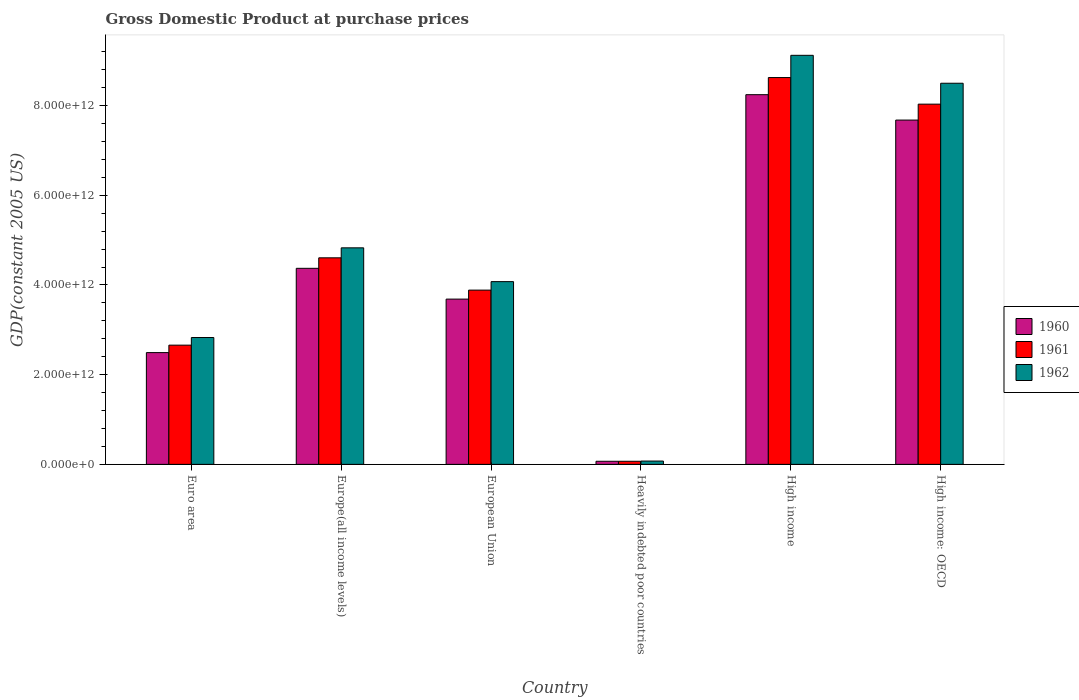How many groups of bars are there?
Provide a short and direct response. 6. Are the number of bars per tick equal to the number of legend labels?
Offer a very short reply. Yes. Are the number of bars on each tick of the X-axis equal?
Your answer should be very brief. Yes. How many bars are there on the 6th tick from the left?
Your answer should be compact. 3. What is the label of the 6th group of bars from the left?
Your answer should be very brief. High income: OECD. What is the GDP at purchase prices in 1961 in High income?
Provide a succinct answer. 8.62e+12. Across all countries, what is the maximum GDP at purchase prices in 1960?
Make the answer very short. 8.24e+12. Across all countries, what is the minimum GDP at purchase prices in 1961?
Keep it short and to the point. 6.91e+1. In which country was the GDP at purchase prices in 1962 maximum?
Give a very brief answer. High income. In which country was the GDP at purchase prices in 1960 minimum?
Keep it short and to the point. Heavily indebted poor countries. What is the total GDP at purchase prices in 1962 in the graph?
Your answer should be compact. 2.94e+13. What is the difference between the GDP at purchase prices in 1961 in Euro area and that in Heavily indebted poor countries?
Keep it short and to the point. 2.59e+12. What is the difference between the GDP at purchase prices in 1962 in European Union and the GDP at purchase prices in 1960 in Europe(all income levels)?
Give a very brief answer. -2.97e+11. What is the average GDP at purchase prices in 1962 per country?
Your answer should be compact. 4.90e+12. What is the difference between the GDP at purchase prices of/in 1961 and GDP at purchase prices of/in 1960 in Euro area?
Provide a short and direct response. 1.66e+11. In how many countries, is the GDP at purchase prices in 1962 greater than 7200000000000 US$?
Offer a very short reply. 2. What is the ratio of the GDP at purchase prices in 1961 in Euro area to that in High income: OECD?
Offer a very short reply. 0.33. Is the GDP at purchase prices in 1961 in Europe(all income levels) less than that in European Union?
Your answer should be very brief. No. Is the difference between the GDP at purchase prices in 1961 in European Union and High income greater than the difference between the GDP at purchase prices in 1960 in European Union and High income?
Provide a succinct answer. No. What is the difference between the highest and the second highest GDP at purchase prices in 1960?
Offer a very short reply. 3.87e+12. What is the difference between the highest and the lowest GDP at purchase prices in 1961?
Ensure brevity in your answer.  8.55e+12. In how many countries, is the GDP at purchase prices in 1961 greater than the average GDP at purchase prices in 1961 taken over all countries?
Offer a very short reply. 2. What does the 1st bar from the right in European Union represents?
Your response must be concise. 1962. How many bars are there?
Give a very brief answer. 18. How many countries are there in the graph?
Offer a terse response. 6. What is the difference between two consecutive major ticks on the Y-axis?
Offer a terse response. 2.00e+12. Where does the legend appear in the graph?
Your response must be concise. Center right. How many legend labels are there?
Ensure brevity in your answer.  3. How are the legend labels stacked?
Make the answer very short. Vertical. What is the title of the graph?
Give a very brief answer. Gross Domestic Product at purchase prices. What is the label or title of the X-axis?
Give a very brief answer. Country. What is the label or title of the Y-axis?
Provide a succinct answer. GDP(constant 2005 US). What is the GDP(constant 2005 US) in 1960 in Euro area?
Your response must be concise. 2.49e+12. What is the GDP(constant 2005 US) of 1961 in Euro area?
Provide a short and direct response. 2.66e+12. What is the GDP(constant 2005 US) of 1962 in Euro area?
Offer a terse response. 2.83e+12. What is the GDP(constant 2005 US) in 1960 in Europe(all income levels)?
Make the answer very short. 4.37e+12. What is the GDP(constant 2005 US) of 1961 in Europe(all income levels)?
Keep it short and to the point. 4.60e+12. What is the GDP(constant 2005 US) of 1962 in Europe(all income levels)?
Your answer should be very brief. 4.83e+12. What is the GDP(constant 2005 US) in 1960 in European Union?
Your answer should be compact. 3.68e+12. What is the GDP(constant 2005 US) in 1961 in European Union?
Make the answer very short. 3.88e+12. What is the GDP(constant 2005 US) in 1962 in European Union?
Provide a succinct answer. 4.07e+12. What is the GDP(constant 2005 US) in 1960 in Heavily indebted poor countries?
Your answer should be compact. 6.90e+1. What is the GDP(constant 2005 US) in 1961 in Heavily indebted poor countries?
Offer a very short reply. 6.91e+1. What is the GDP(constant 2005 US) of 1962 in Heavily indebted poor countries?
Provide a succinct answer. 7.41e+1. What is the GDP(constant 2005 US) of 1960 in High income?
Make the answer very short. 8.24e+12. What is the GDP(constant 2005 US) in 1961 in High income?
Provide a short and direct response. 8.62e+12. What is the GDP(constant 2005 US) of 1962 in High income?
Ensure brevity in your answer.  9.12e+12. What is the GDP(constant 2005 US) of 1960 in High income: OECD?
Make the answer very short. 7.68e+12. What is the GDP(constant 2005 US) of 1961 in High income: OECD?
Your answer should be very brief. 8.03e+12. What is the GDP(constant 2005 US) of 1962 in High income: OECD?
Provide a succinct answer. 8.50e+12. Across all countries, what is the maximum GDP(constant 2005 US) of 1960?
Make the answer very short. 8.24e+12. Across all countries, what is the maximum GDP(constant 2005 US) of 1961?
Offer a terse response. 8.62e+12. Across all countries, what is the maximum GDP(constant 2005 US) of 1962?
Ensure brevity in your answer.  9.12e+12. Across all countries, what is the minimum GDP(constant 2005 US) of 1960?
Make the answer very short. 6.90e+1. Across all countries, what is the minimum GDP(constant 2005 US) in 1961?
Keep it short and to the point. 6.91e+1. Across all countries, what is the minimum GDP(constant 2005 US) of 1962?
Offer a terse response. 7.41e+1. What is the total GDP(constant 2005 US) in 1960 in the graph?
Provide a short and direct response. 2.65e+13. What is the total GDP(constant 2005 US) in 1961 in the graph?
Keep it short and to the point. 2.79e+13. What is the total GDP(constant 2005 US) of 1962 in the graph?
Your response must be concise. 2.94e+13. What is the difference between the GDP(constant 2005 US) in 1960 in Euro area and that in Europe(all income levels)?
Provide a short and direct response. -1.88e+12. What is the difference between the GDP(constant 2005 US) of 1961 in Euro area and that in Europe(all income levels)?
Keep it short and to the point. -1.95e+12. What is the difference between the GDP(constant 2005 US) in 1962 in Euro area and that in Europe(all income levels)?
Keep it short and to the point. -2.00e+12. What is the difference between the GDP(constant 2005 US) in 1960 in Euro area and that in European Union?
Give a very brief answer. -1.19e+12. What is the difference between the GDP(constant 2005 US) in 1961 in Euro area and that in European Union?
Provide a succinct answer. -1.23e+12. What is the difference between the GDP(constant 2005 US) of 1962 in Euro area and that in European Union?
Give a very brief answer. -1.25e+12. What is the difference between the GDP(constant 2005 US) in 1960 in Euro area and that in Heavily indebted poor countries?
Keep it short and to the point. 2.42e+12. What is the difference between the GDP(constant 2005 US) in 1961 in Euro area and that in Heavily indebted poor countries?
Ensure brevity in your answer.  2.59e+12. What is the difference between the GDP(constant 2005 US) in 1962 in Euro area and that in Heavily indebted poor countries?
Keep it short and to the point. 2.75e+12. What is the difference between the GDP(constant 2005 US) in 1960 in Euro area and that in High income?
Make the answer very short. -5.75e+12. What is the difference between the GDP(constant 2005 US) of 1961 in Euro area and that in High income?
Ensure brevity in your answer.  -5.97e+12. What is the difference between the GDP(constant 2005 US) in 1962 in Euro area and that in High income?
Make the answer very short. -6.29e+12. What is the difference between the GDP(constant 2005 US) of 1960 in Euro area and that in High income: OECD?
Provide a succinct answer. -5.18e+12. What is the difference between the GDP(constant 2005 US) in 1961 in Euro area and that in High income: OECD?
Your response must be concise. -5.37e+12. What is the difference between the GDP(constant 2005 US) of 1962 in Euro area and that in High income: OECD?
Make the answer very short. -5.67e+12. What is the difference between the GDP(constant 2005 US) in 1960 in Europe(all income levels) and that in European Union?
Make the answer very short. 6.86e+11. What is the difference between the GDP(constant 2005 US) of 1961 in Europe(all income levels) and that in European Union?
Offer a terse response. 7.20e+11. What is the difference between the GDP(constant 2005 US) of 1962 in Europe(all income levels) and that in European Union?
Ensure brevity in your answer.  7.53e+11. What is the difference between the GDP(constant 2005 US) of 1960 in Europe(all income levels) and that in Heavily indebted poor countries?
Ensure brevity in your answer.  4.30e+12. What is the difference between the GDP(constant 2005 US) of 1961 in Europe(all income levels) and that in Heavily indebted poor countries?
Make the answer very short. 4.54e+12. What is the difference between the GDP(constant 2005 US) in 1962 in Europe(all income levels) and that in Heavily indebted poor countries?
Offer a terse response. 4.75e+12. What is the difference between the GDP(constant 2005 US) of 1960 in Europe(all income levels) and that in High income?
Provide a succinct answer. -3.87e+12. What is the difference between the GDP(constant 2005 US) in 1961 in Europe(all income levels) and that in High income?
Make the answer very short. -4.02e+12. What is the difference between the GDP(constant 2005 US) in 1962 in Europe(all income levels) and that in High income?
Ensure brevity in your answer.  -4.29e+12. What is the difference between the GDP(constant 2005 US) in 1960 in Europe(all income levels) and that in High income: OECD?
Offer a terse response. -3.30e+12. What is the difference between the GDP(constant 2005 US) in 1961 in Europe(all income levels) and that in High income: OECD?
Make the answer very short. -3.43e+12. What is the difference between the GDP(constant 2005 US) of 1962 in Europe(all income levels) and that in High income: OECD?
Your answer should be compact. -3.67e+12. What is the difference between the GDP(constant 2005 US) in 1960 in European Union and that in Heavily indebted poor countries?
Provide a short and direct response. 3.62e+12. What is the difference between the GDP(constant 2005 US) in 1961 in European Union and that in Heavily indebted poor countries?
Provide a succinct answer. 3.82e+12. What is the difference between the GDP(constant 2005 US) in 1962 in European Union and that in Heavily indebted poor countries?
Give a very brief answer. 4.00e+12. What is the difference between the GDP(constant 2005 US) in 1960 in European Union and that in High income?
Offer a very short reply. -4.56e+12. What is the difference between the GDP(constant 2005 US) in 1961 in European Union and that in High income?
Your response must be concise. -4.74e+12. What is the difference between the GDP(constant 2005 US) in 1962 in European Union and that in High income?
Your answer should be very brief. -5.04e+12. What is the difference between the GDP(constant 2005 US) in 1960 in European Union and that in High income: OECD?
Provide a short and direct response. -3.99e+12. What is the difference between the GDP(constant 2005 US) in 1961 in European Union and that in High income: OECD?
Your response must be concise. -4.15e+12. What is the difference between the GDP(constant 2005 US) of 1962 in European Union and that in High income: OECD?
Your answer should be very brief. -4.42e+12. What is the difference between the GDP(constant 2005 US) of 1960 in Heavily indebted poor countries and that in High income?
Your answer should be very brief. -8.17e+12. What is the difference between the GDP(constant 2005 US) in 1961 in Heavily indebted poor countries and that in High income?
Provide a short and direct response. -8.55e+12. What is the difference between the GDP(constant 2005 US) in 1962 in Heavily indebted poor countries and that in High income?
Your answer should be very brief. -9.04e+12. What is the difference between the GDP(constant 2005 US) of 1960 in Heavily indebted poor countries and that in High income: OECD?
Offer a terse response. -7.61e+12. What is the difference between the GDP(constant 2005 US) of 1961 in Heavily indebted poor countries and that in High income: OECD?
Offer a terse response. -7.96e+12. What is the difference between the GDP(constant 2005 US) in 1962 in Heavily indebted poor countries and that in High income: OECD?
Provide a short and direct response. -8.42e+12. What is the difference between the GDP(constant 2005 US) in 1960 in High income and that in High income: OECD?
Give a very brief answer. 5.66e+11. What is the difference between the GDP(constant 2005 US) in 1961 in High income and that in High income: OECD?
Keep it short and to the point. 5.93e+11. What is the difference between the GDP(constant 2005 US) in 1962 in High income and that in High income: OECD?
Your response must be concise. 6.22e+11. What is the difference between the GDP(constant 2005 US) of 1960 in Euro area and the GDP(constant 2005 US) of 1961 in Europe(all income levels)?
Give a very brief answer. -2.11e+12. What is the difference between the GDP(constant 2005 US) in 1960 in Euro area and the GDP(constant 2005 US) in 1962 in Europe(all income levels)?
Your answer should be very brief. -2.34e+12. What is the difference between the GDP(constant 2005 US) of 1961 in Euro area and the GDP(constant 2005 US) of 1962 in Europe(all income levels)?
Offer a very short reply. -2.17e+12. What is the difference between the GDP(constant 2005 US) in 1960 in Euro area and the GDP(constant 2005 US) in 1961 in European Union?
Your answer should be compact. -1.39e+12. What is the difference between the GDP(constant 2005 US) in 1960 in Euro area and the GDP(constant 2005 US) in 1962 in European Union?
Provide a short and direct response. -1.58e+12. What is the difference between the GDP(constant 2005 US) of 1961 in Euro area and the GDP(constant 2005 US) of 1962 in European Union?
Keep it short and to the point. -1.42e+12. What is the difference between the GDP(constant 2005 US) in 1960 in Euro area and the GDP(constant 2005 US) in 1961 in Heavily indebted poor countries?
Your answer should be very brief. 2.42e+12. What is the difference between the GDP(constant 2005 US) in 1960 in Euro area and the GDP(constant 2005 US) in 1962 in Heavily indebted poor countries?
Provide a succinct answer. 2.42e+12. What is the difference between the GDP(constant 2005 US) in 1961 in Euro area and the GDP(constant 2005 US) in 1962 in Heavily indebted poor countries?
Offer a very short reply. 2.58e+12. What is the difference between the GDP(constant 2005 US) of 1960 in Euro area and the GDP(constant 2005 US) of 1961 in High income?
Ensure brevity in your answer.  -6.13e+12. What is the difference between the GDP(constant 2005 US) of 1960 in Euro area and the GDP(constant 2005 US) of 1962 in High income?
Give a very brief answer. -6.63e+12. What is the difference between the GDP(constant 2005 US) of 1961 in Euro area and the GDP(constant 2005 US) of 1962 in High income?
Provide a succinct answer. -6.46e+12. What is the difference between the GDP(constant 2005 US) of 1960 in Euro area and the GDP(constant 2005 US) of 1961 in High income: OECD?
Provide a short and direct response. -5.54e+12. What is the difference between the GDP(constant 2005 US) of 1960 in Euro area and the GDP(constant 2005 US) of 1962 in High income: OECD?
Your response must be concise. -6.00e+12. What is the difference between the GDP(constant 2005 US) of 1961 in Euro area and the GDP(constant 2005 US) of 1962 in High income: OECD?
Your answer should be compact. -5.84e+12. What is the difference between the GDP(constant 2005 US) of 1960 in Europe(all income levels) and the GDP(constant 2005 US) of 1961 in European Union?
Your answer should be compact. 4.86e+11. What is the difference between the GDP(constant 2005 US) of 1960 in Europe(all income levels) and the GDP(constant 2005 US) of 1962 in European Union?
Provide a short and direct response. 2.97e+11. What is the difference between the GDP(constant 2005 US) in 1961 in Europe(all income levels) and the GDP(constant 2005 US) in 1962 in European Union?
Offer a terse response. 5.31e+11. What is the difference between the GDP(constant 2005 US) of 1960 in Europe(all income levels) and the GDP(constant 2005 US) of 1961 in Heavily indebted poor countries?
Offer a terse response. 4.30e+12. What is the difference between the GDP(constant 2005 US) in 1960 in Europe(all income levels) and the GDP(constant 2005 US) in 1962 in Heavily indebted poor countries?
Provide a succinct answer. 4.30e+12. What is the difference between the GDP(constant 2005 US) in 1961 in Europe(all income levels) and the GDP(constant 2005 US) in 1962 in Heavily indebted poor countries?
Your answer should be very brief. 4.53e+12. What is the difference between the GDP(constant 2005 US) in 1960 in Europe(all income levels) and the GDP(constant 2005 US) in 1961 in High income?
Your response must be concise. -4.25e+12. What is the difference between the GDP(constant 2005 US) of 1960 in Europe(all income levels) and the GDP(constant 2005 US) of 1962 in High income?
Give a very brief answer. -4.75e+12. What is the difference between the GDP(constant 2005 US) in 1961 in Europe(all income levels) and the GDP(constant 2005 US) in 1962 in High income?
Your response must be concise. -4.51e+12. What is the difference between the GDP(constant 2005 US) of 1960 in Europe(all income levels) and the GDP(constant 2005 US) of 1961 in High income: OECD?
Offer a terse response. -3.66e+12. What is the difference between the GDP(constant 2005 US) of 1960 in Europe(all income levels) and the GDP(constant 2005 US) of 1962 in High income: OECD?
Ensure brevity in your answer.  -4.13e+12. What is the difference between the GDP(constant 2005 US) in 1961 in Europe(all income levels) and the GDP(constant 2005 US) in 1962 in High income: OECD?
Offer a terse response. -3.89e+12. What is the difference between the GDP(constant 2005 US) of 1960 in European Union and the GDP(constant 2005 US) of 1961 in Heavily indebted poor countries?
Ensure brevity in your answer.  3.62e+12. What is the difference between the GDP(constant 2005 US) of 1960 in European Union and the GDP(constant 2005 US) of 1962 in Heavily indebted poor countries?
Give a very brief answer. 3.61e+12. What is the difference between the GDP(constant 2005 US) in 1961 in European Union and the GDP(constant 2005 US) in 1962 in Heavily indebted poor countries?
Keep it short and to the point. 3.81e+12. What is the difference between the GDP(constant 2005 US) in 1960 in European Union and the GDP(constant 2005 US) in 1961 in High income?
Provide a short and direct response. -4.94e+12. What is the difference between the GDP(constant 2005 US) of 1960 in European Union and the GDP(constant 2005 US) of 1962 in High income?
Keep it short and to the point. -5.43e+12. What is the difference between the GDP(constant 2005 US) in 1961 in European Union and the GDP(constant 2005 US) in 1962 in High income?
Give a very brief answer. -5.23e+12. What is the difference between the GDP(constant 2005 US) of 1960 in European Union and the GDP(constant 2005 US) of 1961 in High income: OECD?
Keep it short and to the point. -4.35e+12. What is the difference between the GDP(constant 2005 US) in 1960 in European Union and the GDP(constant 2005 US) in 1962 in High income: OECD?
Provide a short and direct response. -4.81e+12. What is the difference between the GDP(constant 2005 US) in 1961 in European Union and the GDP(constant 2005 US) in 1962 in High income: OECD?
Your answer should be very brief. -4.61e+12. What is the difference between the GDP(constant 2005 US) in 1960 in Heavily indebted poor countries and the GDP(constant 2005 US) in 1961 in High income?
Provide a short and direct response. -8.55e+12. What is the difference between the GDP(constant 2005 US) in 1960 in Heavily indebted poor countries and the GDP(constant 2005 US) in 1962 in High income?
Keep it short and to the point. -9.05e+12. What is the difference between the GDP(constant 2005 US) of 1961 in Heavily indebted poor countries and the GDP(constant 2005 US) of 1962 in High income?
Provide a succinct answer. -9.05e+12. What is the difference between the GDP(constant 2005 US) of 1960 in Heavily indebted poor countries and the GDP(constant 2005 US) of 1961 in High income: OECD?
Ensure brevity in your answer.  -7.96e+12. What is the difference between the GDP(constant 2005 US) in 1960 in Heavily indebted poor countries and the GDP(constant 2005 US) in 1962 in High income: OECD?
Give a very brief answer. -8.43e+12. What is the difference between the GDP(constant 2005 US) of 1961 in Heavily indebted poor countries and the GDP(constant 2005 US) of 1962 in High income: OECD?
Offer a terse response. -8.43e+12. What is the difference between the GDP(constant 2005 US) in 1960 in High income and the GDP(constant 2005 US) in 1961 in High income: OECD?
Make the answer very short. 2.11e+11. What is the difference between the GDP(constant 2005 US) in 1960 in High income and the GDP(constant 2005 US) in 1962 in High income: OECD?
Provide a succinct answer. -2.55e+11. What is the difference between the GDP(constant 2005 US) in 1961 in High income and the GDP(constant 2005 US) in 1962 in High income: OECD?
Your response must be concise. 1.27e+11. What is the average GDP(constant 2005 US) in 1960 per country?
Offer a terse response. 4.42e+12. What is the average GDP(constant 2005 US) in 1961 per country?
Offer a terse response. 4.65e+12. What is the average GDP(constant 2005 US) of 1962 per country?
Provide a short and direct response. 4.90e+12. What is the difference between the GDP(constant 2005 US) of 1960 and GDP(constant 2005 US) of 1961 in Euro area?
Your response must be concise. -1.66e+11. What is the difference between the GDP(constant 2005 US) in 1960 and GDP(constant 2005 US) in 1962 in Euro area?
Give a very brief answer. -3.36e+11. What is the difference between the GDP(constant 2005 US) in 1961 and GDP(constant 2005 US) in 1962 in Euro area?
Keep it short and to the point. -1.70e+11. What is the difference between the GDP(constant 2005 US) in 1960 and GDP(constant 2005 US) in 1961 in Europe(all income levels)?
Ensure brevity in your answer.  -2.34e+11. What is the difference between the GDP(constant 2005 US) in 1960 and GDP(constant 2005 US) in 1962 in Europe(all income levels)?
Ensure brevity in your answer.  -4.57e+11. What is the difference between the GDP(constant 2005 US) of 1961 and GDP(constant 2005 US) of 1962 in Europe(all income levels)?
Offer a very short reply. -2.23e+11. What is the difference between the GDP(constant 2005 US) in 1960 and GDP(constant 2005 US) in 1961 in European Union?
Offer a very short reply. -2.00e+11. What is the difference between the GDP(constant 2005 US) of 1960 and GDP(constant 2005 US) of 1962 in European Union?
Keep it short and to the point. -3.89e+11. What is the difference between the GDP(constant 2005 US) of 1961 and GDP(constant 2005 US) of 1962 in European Union?
Offer a terse response. -1.89e+11. What is the difference between the GDP(constant 2005 US) of 1960 and GDP(constant 2005 US) of 1961 in Heavily indebted poor countries?
Ensure brevity in your answer.  -9.28e+07. What is the difference between the GDP(constant 2005 US) in 1960 and GDP(constant 2005 US) in 1962 in Heavily indebted poor countries?
Give a very brief answer. -5.08e+09. What is the difference between the GDP(constant 2005 US) in 1961 and GDP(constant 2005 US) in 1962 in Heavily indebted poor countries?
Make the answer very short. -4.99e+09. What is the difference between the GDP(constant 2005 US) of 1960 and GDP(constant 2005 US) of 1961 in High income?
Offer a terse response. -3.82e+11. What is the difference between the GDP(constant 2005 US) in 1960 and GDP(constant 2005 US) in 1962 in High income?
Your answer should be very brief. -8.77e+11. What is the difference between the GDP(constant 2005 US) in 1961 and GDP(constant 2005 US) in 1962 in High income?
Offer a very short reply. -4.95e+11. What is the difference between the GDP(constant 2005 US) of 1960 and GDP(constant 2005 US) of 1961 in High income: OECD?
Your answer should be very brief. -3.55e+11. What is the difference between the GDP(constant 2005 US) in 1960 and GDP(constant 2005 US) in 1962 in High income: OECD?
Your answer should be very brief. -8.21e+11. What is the difference between the GDP(constant 2005 US) of 1961 and GDP(constant 2005 US) of 1962 in High income: OECD?
Offer a very short reply. -4.66e+11. What is the ratio of the GDP(constant 2005 US) in 1960 in Euro area to that in Europe(all income levels)?
Provide a succinct answer. 0.57. What is the ratio of the GDP(constant 2005 US) in 1961 in Euro area to that in Europe(all income levels)?
Provide a short and direct response. 0.58. What is the ratio of the GDP(constant 2005 US) of 1962 in Euro area to that in Europe(all income levels)?
Provide a short and direct response. 0.59. What is the ratio of the GDP(constant 2005 US) of 1960 in Euro area to that in European Union?
Offer a very short reply. 0.68. What is the ratio of the GDP(constant 2005 US) in 1961 in Euro area to that in European Union?
Keep it short and to the point. 0.68. What is the ratio of the GDP(constant 2005 US) in 1962 in Euro area to that in European Union?
Make the answer very short. 0.69. What is the ratio of the GDP(constant 2005 US) of 1960 in Euro area to that in Heavily indebted poor countries?
Offer a very short reply. 36.09. What is the ratio of the GDP(constant 2005 US) in 1961 in Euro area to that in Heavily indebted poor countries?
Your answer should be compact. 38.44. What is the ratio of the GDP(constant 2005 US) of 1962 in Euro area to that in Heavily indebted poor countries?
Ensure brevity in your answer.  38.15. What is the ratio of the GDP(constant 2005 US) in 1960 in Euro area to that in High income?
Your answer should be compact. 0.3. What is the ratio of the GDP(constant 2005 US) in 1961 in Euro area to that in High income?
Your answer should be compact. 0.31. What is the ratio of the GDP(constant 2005 US) in 1962 in Euro area to that in High income?
Your response must be concise. 0.31. What is the ratio of the GDP(constant 2005 US) of 1960 in Euro area to that in High income: OECD?
Make the answer very short. 0.32. What is the ratio of the GDP(constant 2005 US) in 1961 in Euro area to that in High income: OECD?
Make the answer very short. 0.33. What is the ratio of the GDP(constant 2005 US) in 1962 in Euro area to that in High income: OECD?
Your answer should be very brief. 0.33. What is the ratio of the GDP(constant 2005 US) in 1960 in Europe(all income levels) to that in European Union?
Provide a succinct answer. 1.19. What is the ratio of the GDP(constant 2005 US) of 1961 in Europe(all income levels) to that in European Union?
Ensure brevity in your answer.  1.19. What is the ratio of the GDP(constant 2005 US) of 1962 in Europe(all income levels) to that in European Union?
Your answer should be compact. 1.19. What is the ratio of the GDP(constant 2005 US) in 1960 in Europe(all income levels) to that in Heavily indebted poor countries?
Give a very brief answer. 63.31. What is the ratio of the GDP(constant 2005 US) in 1961 in Europe(all income levels) to that in Heavily indebted poor countries?
Make the answer very short. 66.6. What is the ratio of the GDP(constant 2005 US) in 1962 in Europe(all income levels) to that in Heavily indebted poor countries?
Your answer should be very brief. 65.13. What is the ratio of the GDP(constant 2005 US) in 1960 in Europe(all income levels) to that in High income?
Make the answer very short. 0.53. What is the ratio of the GDP(constant 2005 US) in 1961 in Europe(all income levels) to that in High income?
Ensure brevity in your answer.  0.53. What is the ratio of the GDP(constant 2005 US) of 1962 in Europe(all income levels) to that in High income?
Ensure brevity in your answer.  0.53. What is the ratio of the GDP(constant 2005 US) in 1960 in Europe(all income levels) to that in High income: OECD?
Your answer should be very brief. 0.57. What is the ratio of the GDP(constant 2005 US) of 1961 in Europe(all income levels) to that in High income: OECD?
Provide a succinct answer. 0.57. What is the ratio of the GDP(constant 2005 US) in 1962 in Europe(all income levels) to that in High income: OECD?
Keep it short and to the point. 0.57. What is the ratio of the GDP(constant 2005 US) of 1960 in European Union to that in Heavily indebted poor countries?
Your answer should be compact. 53.37. What is the ratio of the GDP(constant 2005 US) of 1961 in European Union to that in Heavily indebted poor countries?
Give a very brief answer. 56.19. What is the ratio of the GDP(constant 2005 US) in 1962 in European Union to that in Heavily indebted poor countries?
Give a very brief answer. 54.96. What is the ratio of the GDP(constant 2005 US) of 1960 in European Union to that in High income?
Make the answer very short. 0.45. What is the ratio of the GDP(constant 2005 US) of 1961 in European Union to that in High income?
Provide a succinct answer. 0.45. What is the ratio of the GDP(constant 2005 US) of 1962 in European Union to that in High income?
Give a very brief answer. 0.45. What is the ratio of the GDP(constant 2005 US) of 1960 in European Union to that in High income: OECD?
Your answer should be very brief. 0.48. What is the ratio of the GDP(constant 2005 US) of 1961 in European Union to that in High income: OECD?
Your answer should be very brief. 0.48. What is the ratio of the GDP(constant 2005 US) of 1962 in European Union to that in High income: OECD?
Your answer should be compact. 0.48. What is the ratio of the GDP(constant 2005 US) of 1960 in Heavily indebted poor countries to that in High income?
Make the answer very short. 0.01. What is the ratio of the GDP(constant 2005 US) in 1961 in Heavily indebted poor countries to that in High income?
Offer a terse response. 0.01. What is the ratio of the GDP(constant 2005 US) of 1962 in Heavily indebted poor countries to that in High income?
Your response must be concise. 0.01. What is the ratio of the GDP(constant 2005 US) in 1960 in Heavily indebted poor countries to that in High income: OECD?
Your answer should be compact. 0.01. What is the ratio of the GDP(constant 2005 US) in 1961 in Heavily indebted poor countries to that in High income: OECD?
Keep it short and to the point. 0.01. What is the ratio of the GDP(constant 2005 US) of 1962 in Heavily indebted poor countries to that in High income: OECD?
Offer a terse response. 0.01. What is the ratio of the GDP(constant 2005 US) in 1960 in High income to that in High income: OECD?
Provide a short and direct response. 1.07. What is the ratio of the GDP(constant 2005 US) in 1961 in High income to that in High income: OECD?
Provide a succinct answer. 1.07. What is the ratio of the GDP(constant 2005 US) in 1962 in High income to that in High income: OECD?
Your response must be concise. 1.07. What is the difference between the highest and the second highest GDP(constant 2005 US) of 1960?
Ensure brevity in your answer.  5.66e+11. What is the difference between the highest and the second highest GDP(constant 2005 US) of 1961?
Keep it short and to the point. 5.93e+11. What is the difference between the highest and the second highest GDP(constant 2005 US) of 1962?
Provide a succinct answer. 6.22e+11. What is the difference between the highest and the lowest GDP(constant 2005 US) in 1960?
Offer a terse response. 8.17e+12. What is the difference between the highest and the lowest GDP(constant 2005 US) of 1961?
Give a very brief answer. 8.55e+12. What is the difference between the highest and the lowest GDP(constant 2005 US) of 1962?
Keep it short and to the point. 9.04e+12. 